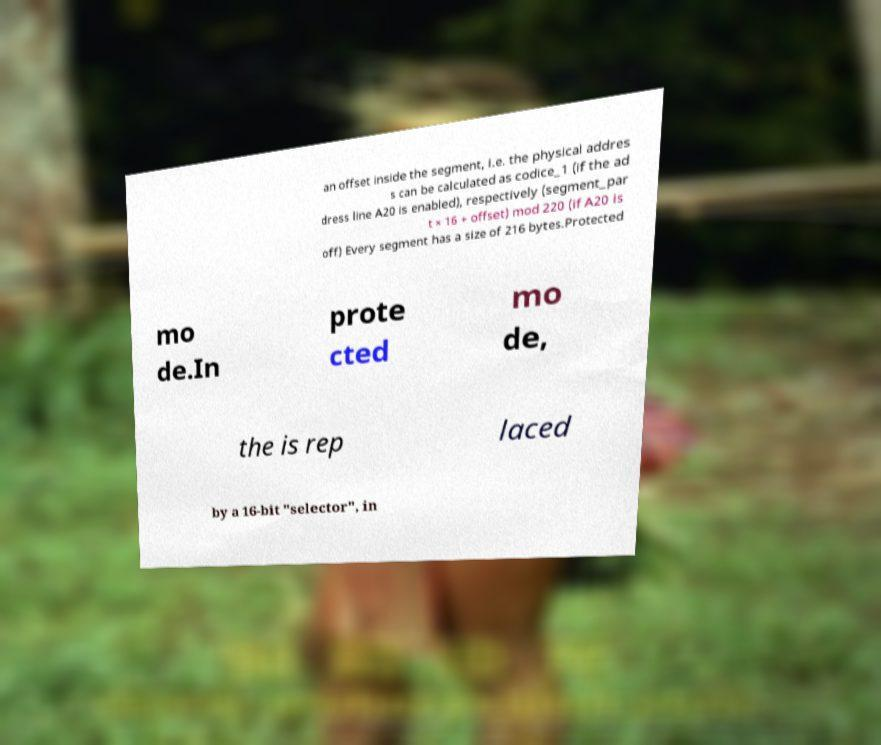For documentation purposes, I need the text within this image transcribed. Could you provide that? an offset inside the segment, i.e. the physical addres s can be calculated as codice_1 (if the ad dress line A20 is enabled), respectively (segment_par t × 16 + offset) mod 220 (if A20 is off) Every segment has a size of 216 bytes.Protected mo de.In prote cted mo de, the is rep laced by a 16-bit "selector", in 